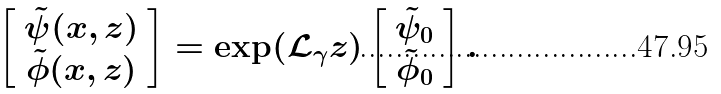Convert formula to latex. <formula><loc_0><loc_0><loc_500><loc_500>\left [ \begin{array} { c } \tilde { \psi } ( x , z ) \\ \tilde { \phi } ( x , z ) \end{array} \right ] = \exp ( \mathcal { L } _ { \gamma } z ) \left [ \begin{array} { c } \tilde { \psi } _ { 0 } \\ \tilde { \phi } _ { 0 } \end{array} \right ] .</formula> 